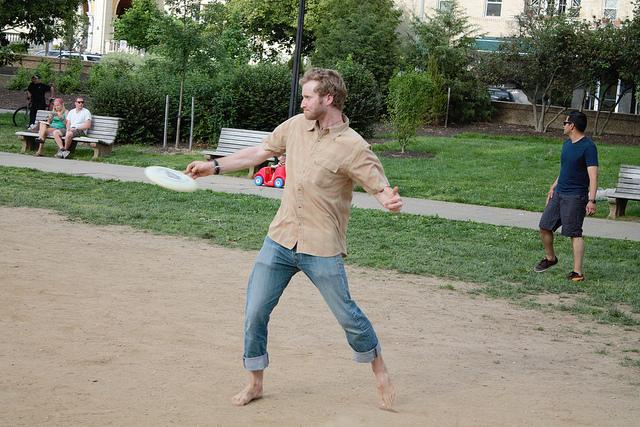How many people are wearing shorts?
Short answer required. 3. What is this person trying to do?
Keep it brief. Throw frisbee. What color is the Frisbee?
Answer briefly. White. What is this sport?
Be succinct. Frisbee. What is the battery for?
Short answer required. Nothing. Is that person a boy or a girl?
Concise answer only. Boy. Are there people sitting on the bench?
Keep it brief. Yes. Are these women?
Answer briefly. No. What color is the person's shirt?
Concise answer only. Tan. What does the man have on his hand?
Keep it brief. Frisbee. Where is the brown belt?
Give a very brief answer. Waist. 